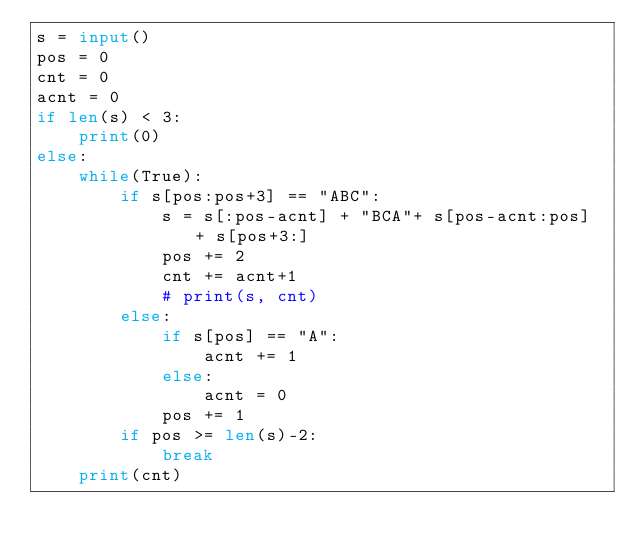Convert code to text. <code><loc_0><loc_0><loc_500><loc_500><_Python_>s = input()
pos = 0
cnt = 0
acnt = 0
if len(s) < 3:
    print(0)
else:
    while(True):
        if s[pos:pos+3] == "ABC":
            s = s[:pos-acnt] + "BCA"+ s[pos-acnt:pos] + s[pos+3:]
            pos += 2
            cnt += acnt+1
            # print(s, cnt)
        else:
            if s[pos] == "A":
                acnt += 1
            else:
                acnt = 0
            pos += 1
        if pos >= len(s)-2:
            break
    print(cnt)
</code> 